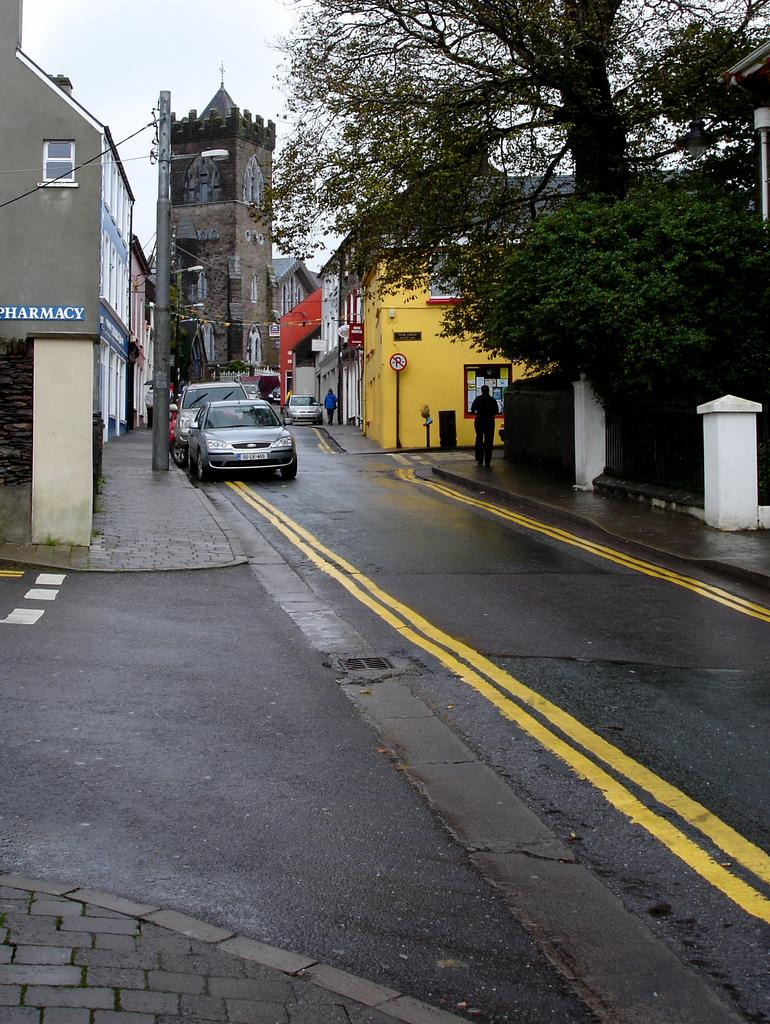What can be seen on the road in the image? There are vehicles on the road in the image. Where are the two people located in the image? The two people are on the footpaths in the image. What type of natural elements are visible in the image? Trees are visible in the image. What type of structures are present in the image? Poles and buildings with windows are in the image. What additional objects can be seen in the image? There are some objects in the image. What is visible in the background of the image? The sky is visible in the background of the image. What type of war is being fought in the image? There is no war present in the image; it features vehicles on the road, people on footpaths, trees, poles, buildings, and the sky. What kind of yarn is being used to create the objects in the image? The objects in the image are not made of yarn; they are solid structures and vehicles. 